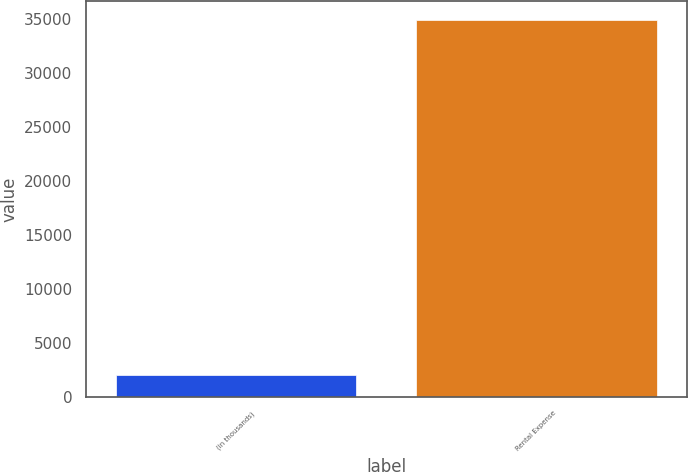Convert chart to OTSL. <chart><loc_0><loc_0><loc_500><loc_500><bar_chart><fcel>(in thousands)<fcel>Rental Expense<nl><fcel>2006<fcel>34858<nl></chart> 